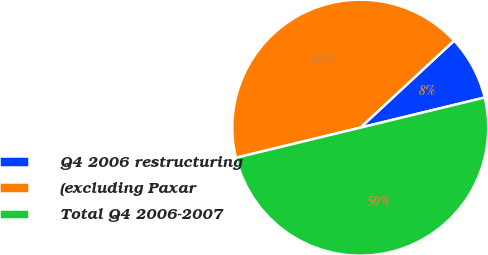<chart> <loc_0><loc_0><loc_500><loc_500><pie_chart><fcel>Q4 2006 restructuring<fcel>(excluding Paxar<fcel>Total Q4 2006-2007<nl><fcel>8.12%<fcel>41.88%<fcel>50.0%<nl></chart> 